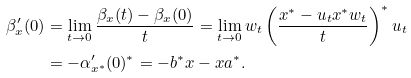<formula> <loc_0><loc_0><loc_500><loc_500>\beta _ { x } ^ { \prime } ( 0 ) & = \lim _ { t \to 0 } \frac { \beta _ { x } ( t ) - \beta _ { x } ( 0 ) } t = \lim _ { t \to 0 } w _ { t } \left ( \frac { x ^ { * } - u _ { t } x ^ { * } w _ { t } } t \right ) ^ { * } u _ { t } \\ & = - \alpha _ { x ^ { * } } ^ { \prime } ( 0 ) ^ { * } = - b ^ { * } x - x a ^ { * } .</formula> 